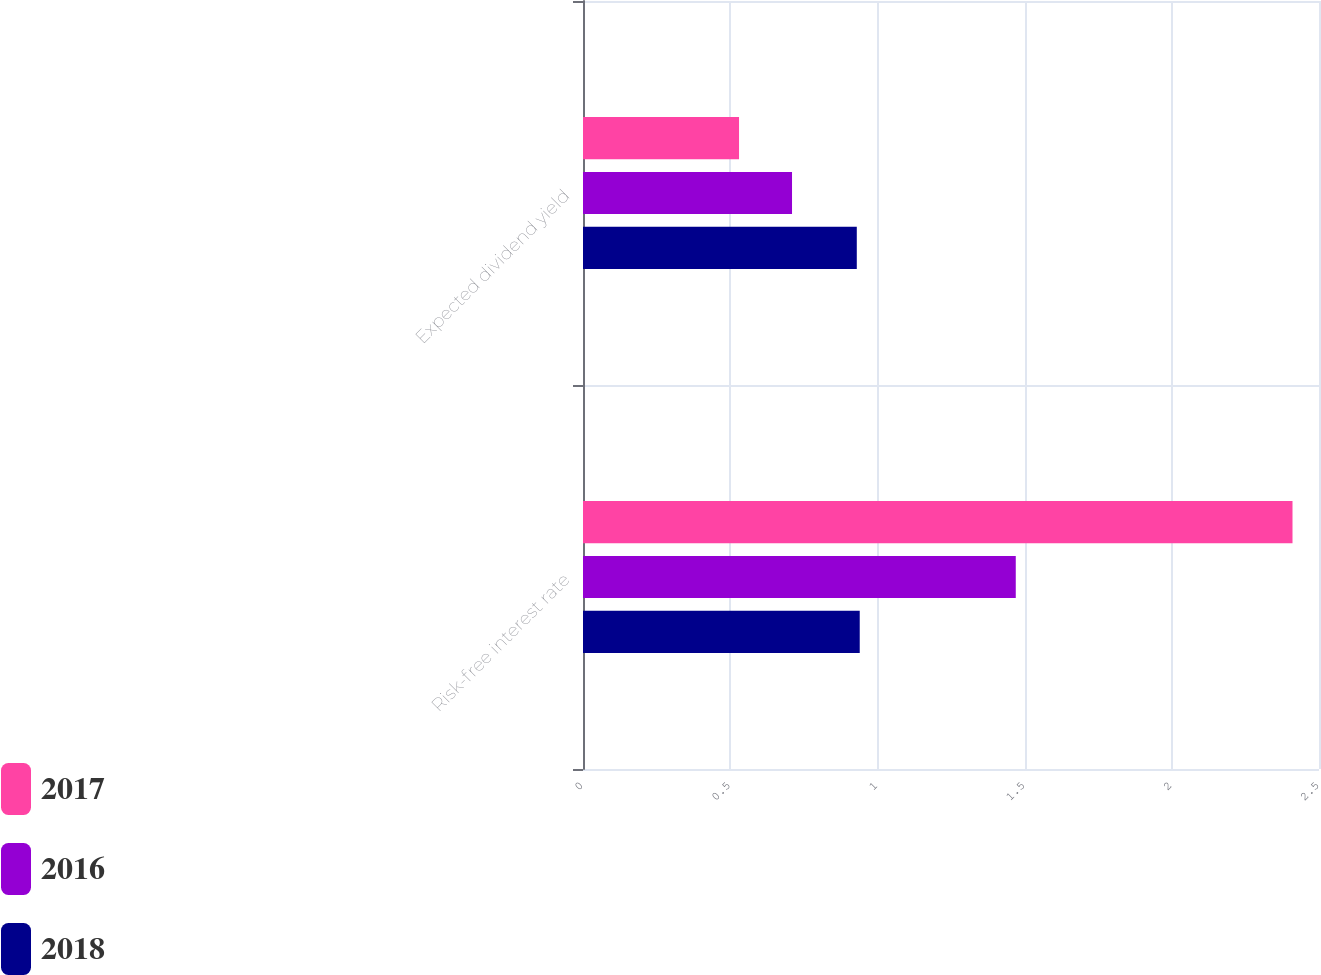Convert chart to OTSL. <chart><loc_0><loc_0><loc_500><loc_500><stacked_bar_chart><ecel><fcel>Risk-free interest rate<fcel>Expected dividend yield<nl><fcel>2017<fcel>2.41<fcel>0.53<nl><fcel>2016<fcel>1.47<fcel>0.71<nl><fcel>2018<fcel>0.94<fcel>0.93<nl></chart> 